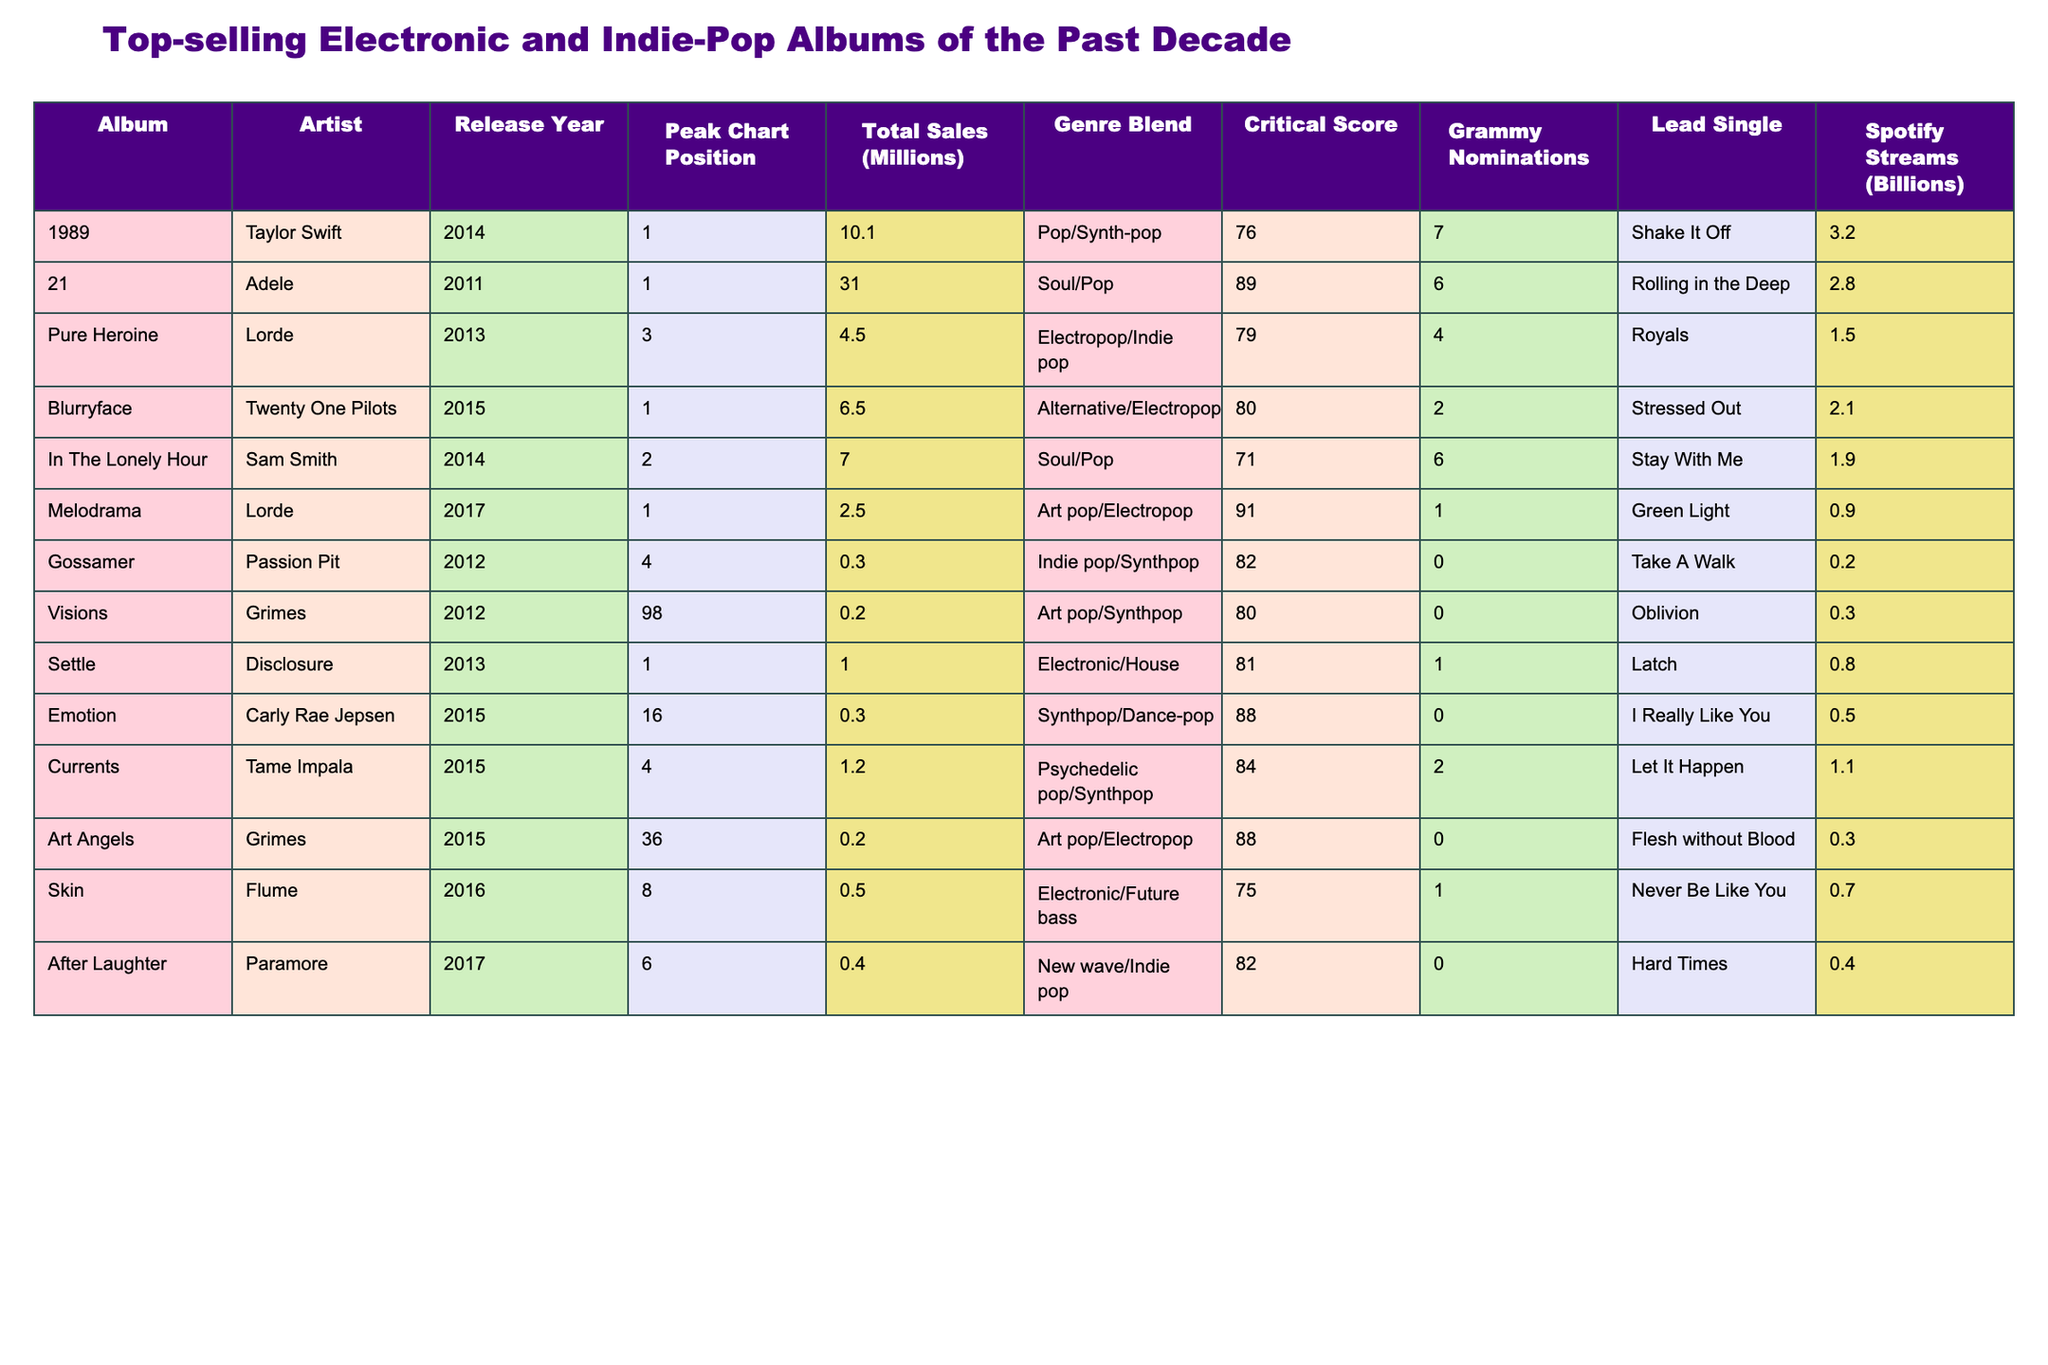What is the total sales of "21" by Adele? The table shows that "21" has total sales of 31.0 million.
Answer: 31.0 million Which album had the highest peak chart position? "21" peaked at position 1, which is the highest among all albums listed.
Answer: "21" How many Grammy nominations did "Pure Heroine" receive? According to the table, "Pure Heroine" received 4 Grammy nominations.
Answer: 4 What is the average total sales of all albums listed? The total sales are (10.1 + 31.0 + 4.5 + 6.5 + 7.0 + 2.5 + 0.3 + 0.2 + 1.0 + 0.3 + 1.2 + 0.5 + 0.4) = 65.5 million across 13 albums. The average is 65.5 / 13 = 5.04 million.
Answer: 5.04 million Which album released in 2015 had the most Spotify streams? "Blurryface" by Twenty One Pilots, released in 2015, has 2.1 billion Spotify streams, more than any other 2015 album listed.
Answer: "Blurryface" Is "Melodrama" by Lorde nominated for a Grammy? Yes, "Melodrama" received 1 Grammy nomination, as stated in the table.
Answer: Yes Which artist has the most albums listed in the table? Adele and Lorde each have two albums listed. Since no other artist has more than one, they have the most.
Answer: Adele and Lorde What is the difference in total sales between "1989" and "In The Lonely Hour"? "1989" has sales of 10.1 million and "In The Lonely Hour" has 7.0 million. The difference is 10.1 - 7.0 = 3.1 million.
Answer: 3.1 million What is the highest critical score among the albums listed? The highest critical score is 91, which belongs to "Melodrama" by Lorde.
Answer: 91 Which album had the lowest total sales, and what was that amount? "Gossamer" by Passion Pit had the lowest total sales at 0.3 million.
Answer: "Gossamer", 0.3 million Which album's lead single is "Stay With Me"? "Stay With Me" is the lead single from "In The Lonely Hour" by Sam Smith.
Answer: "In The Lonely Hour" Does "Settle" have a higher peak chart position than "Emotion"? Yes, "Settle" peaked at position 1 while "Emotion" peaked at position 16.
Answer: Yes What is the total number of Grammy nominations received by the albums listed? The total number of Grammy nominations is (7 + 6 + 4 + 2 + 6 + 1 + 0 + 0 + 1 + 0 + 2 + 0 + 0) = 29.
Answer: 29 Which genre blend has the album "Currents"? "Currents" is categorized under Psychedelic pop/Synthpop.
Answer: Psychedelic pop/Synthpop If we consider only the albums with more than 1 million total sales, how many albums are there? The albums with more than 1 million total sales are "21", "1989", "Blurryface", and "In The Lonely Hour", totaling 4 albums.
Answer: 4 